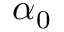<formula> <loc_0><loc_0><loc_500><loc_500>\ \alpha _ { 0 }</formula> 